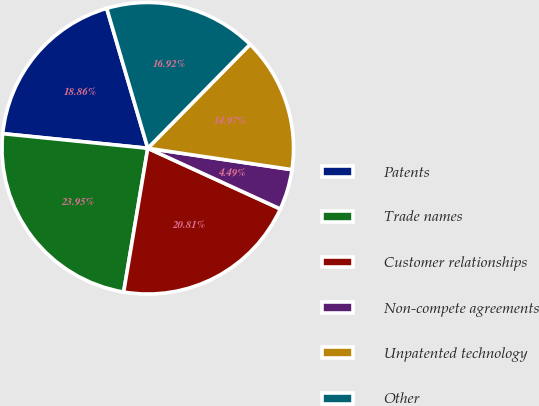Convert chart to OTSL. <chart><loc_0><loc_0><loc_500><loc_500><pie_chart><fcel>Patents<fcel>Trade names<fcel>Customer relationships<fcel>Non-compete agreements<fcel>Unpatented technology<fcel>Other<nl><fcel>18.86%<fcel>23.95%<fcel>20.81%<fcel>4.49%<fcel>14.97%<fcel>16.92%<nl></chart> 